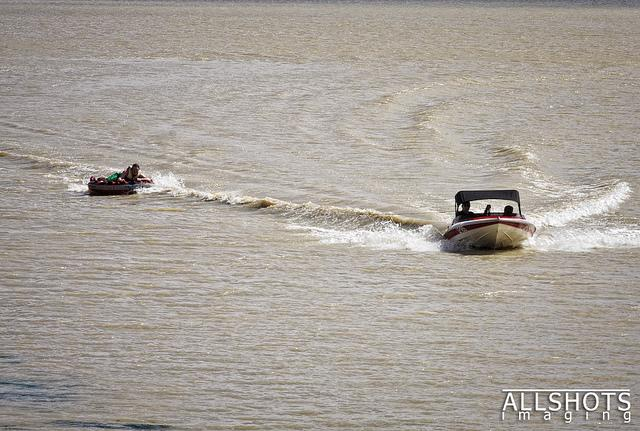How is the small vessel being moved? Please explain your reasoning. towed. The small vessel does not have a motor or a sail. there is a cable that connects the larger vessel to the smaller one. 